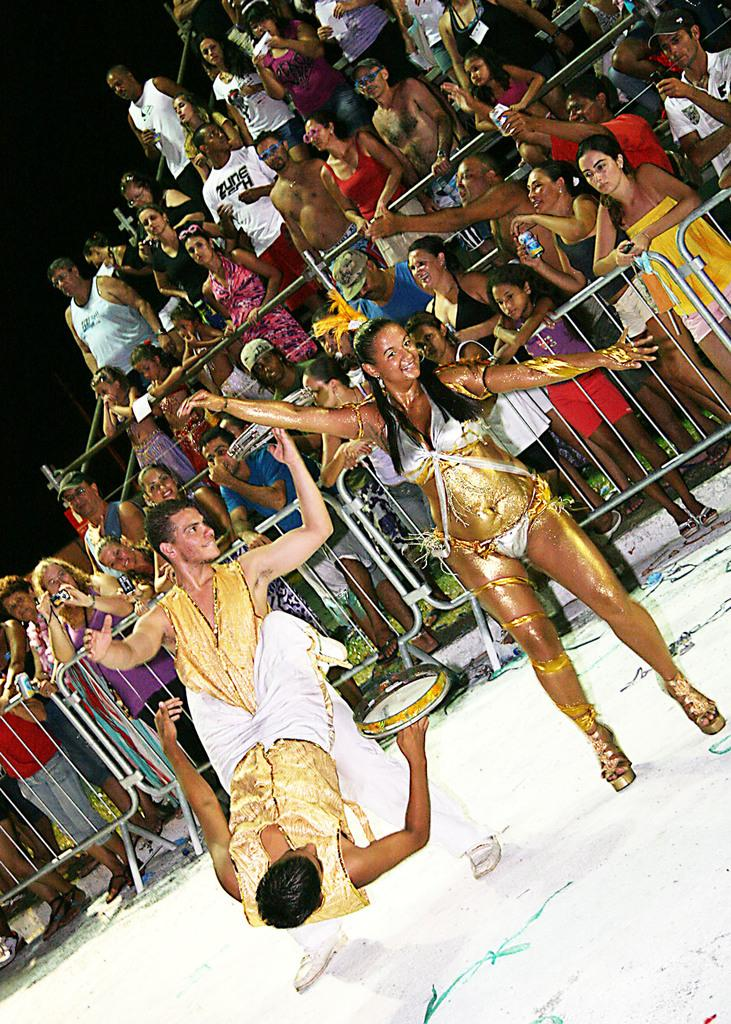What is happening in the foreground of the image? There are three people performing in the foreground of the image. What is the color of the surface they are performing on? The surface they are performing on is white. What can be seen in the background of the image? There are people standing in the background of the image. What type of architectural feature is visible in the image? There are fencing's visible in the image. What type of lunchroom can be seen in the image? There is no lunchroom present in the image. How many facts can be seen in the image? The image itself is not a fact, so it cannot be counted as a fact in the image. 